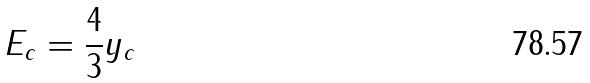<formula> <loc_0><loc_0><loc_500><loc_500>E _ { c } = \frac { 4 } { 3 } y _ { c }</formula> 